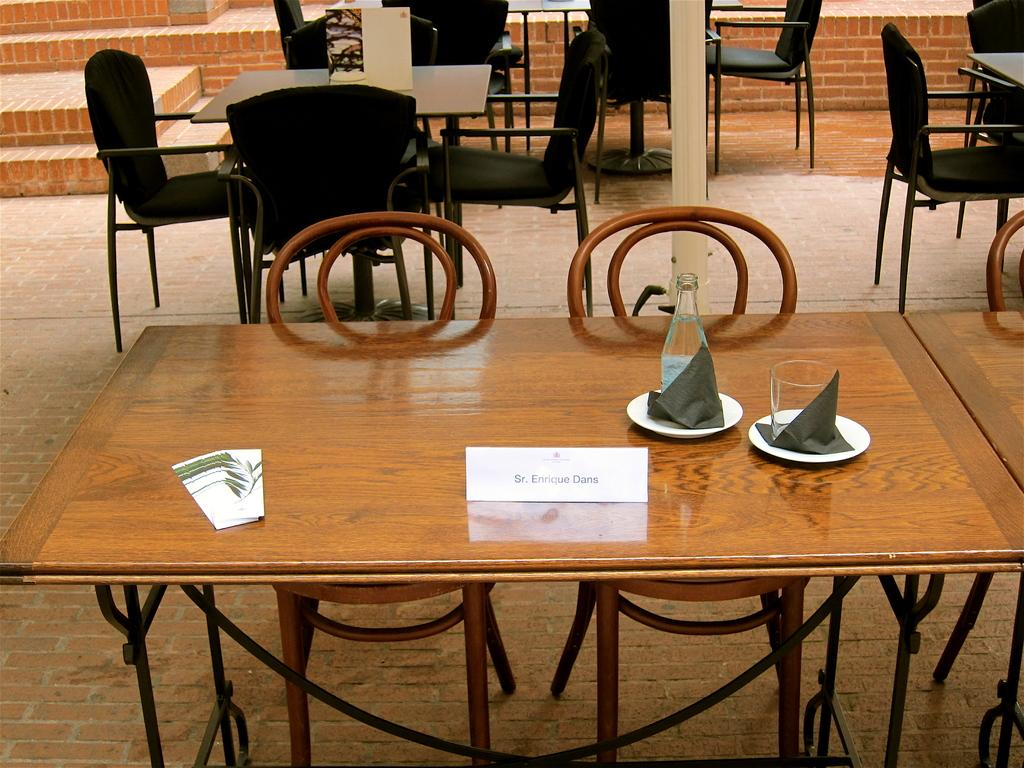What type of establishment is the image taken in? The image is taken in a restaurant. What can be seen in the foreground of the image? There are tables, chairs, bottles, glasses, and other objects in the foreground of the image. Can you describe the objects in the foreground? The objects in the foreground include tables, chairs, bottles, glasses, and other unspecified items. What is visible in the background of the image? There are steps in the background of the image. What time of day is the squirrel enjoying its afternoon snack in the image? There is no squirrel present in the image, and therefore no such activity can be observed. What type of beast is lurking in the background of the image? There are no beasts present in the image; it is taken in a restaurant with steps in the background. 